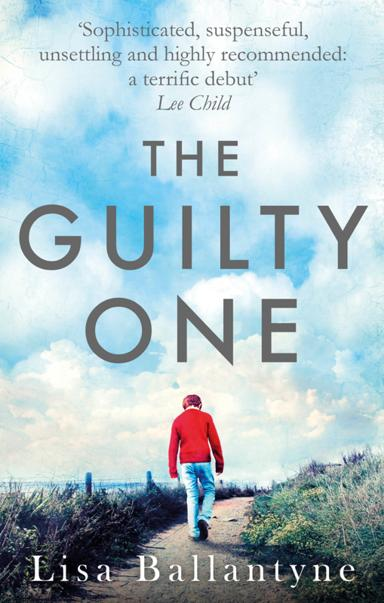What kind of setting can readers expect from this book? The book primarily unfolds in varied settings, including urban courtrooms and quiet rural landscapes, as highlighted by the cover. This juxtaposition provides a rich backdrop that mirrors the internal conflict of the characters and the dramatic legal and moral quandaries they face. Does the setting influence the mood of the story? Absolutely, the settings are crucial in shaping the book's mood. The courtroom scenes often are tense and charged with high stakes, while the rural pathways, like the one on the cover, offer a sense of reflection and emotional depth, intensifying the reader's experience of the characters' personal and ethical struggles. 